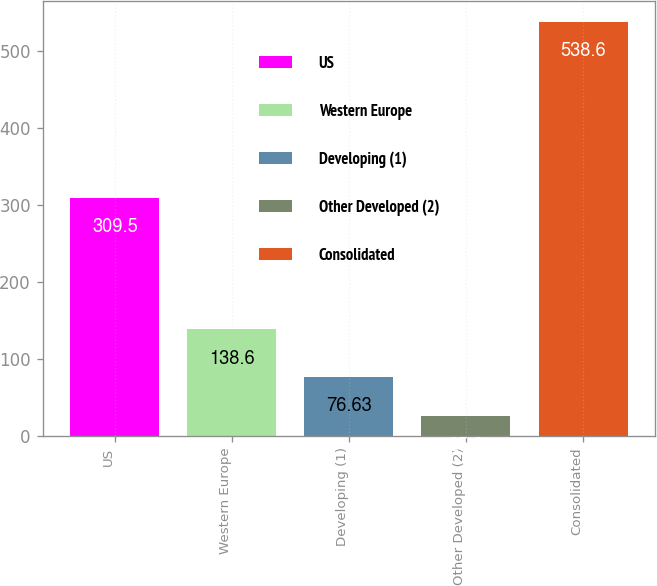<chart> <loc_0><loc_0><loc_500><loc_500><bar_chart><fcel>US<fcel>Western Europe<fcel>Developing (1)<fcel>Other Developed (2)<fcel>Consolidated<nl><fcel>309.5<fcel>138.6<fcel>76.63<fcel>25.3<fcel>538.6<nl></chart> 